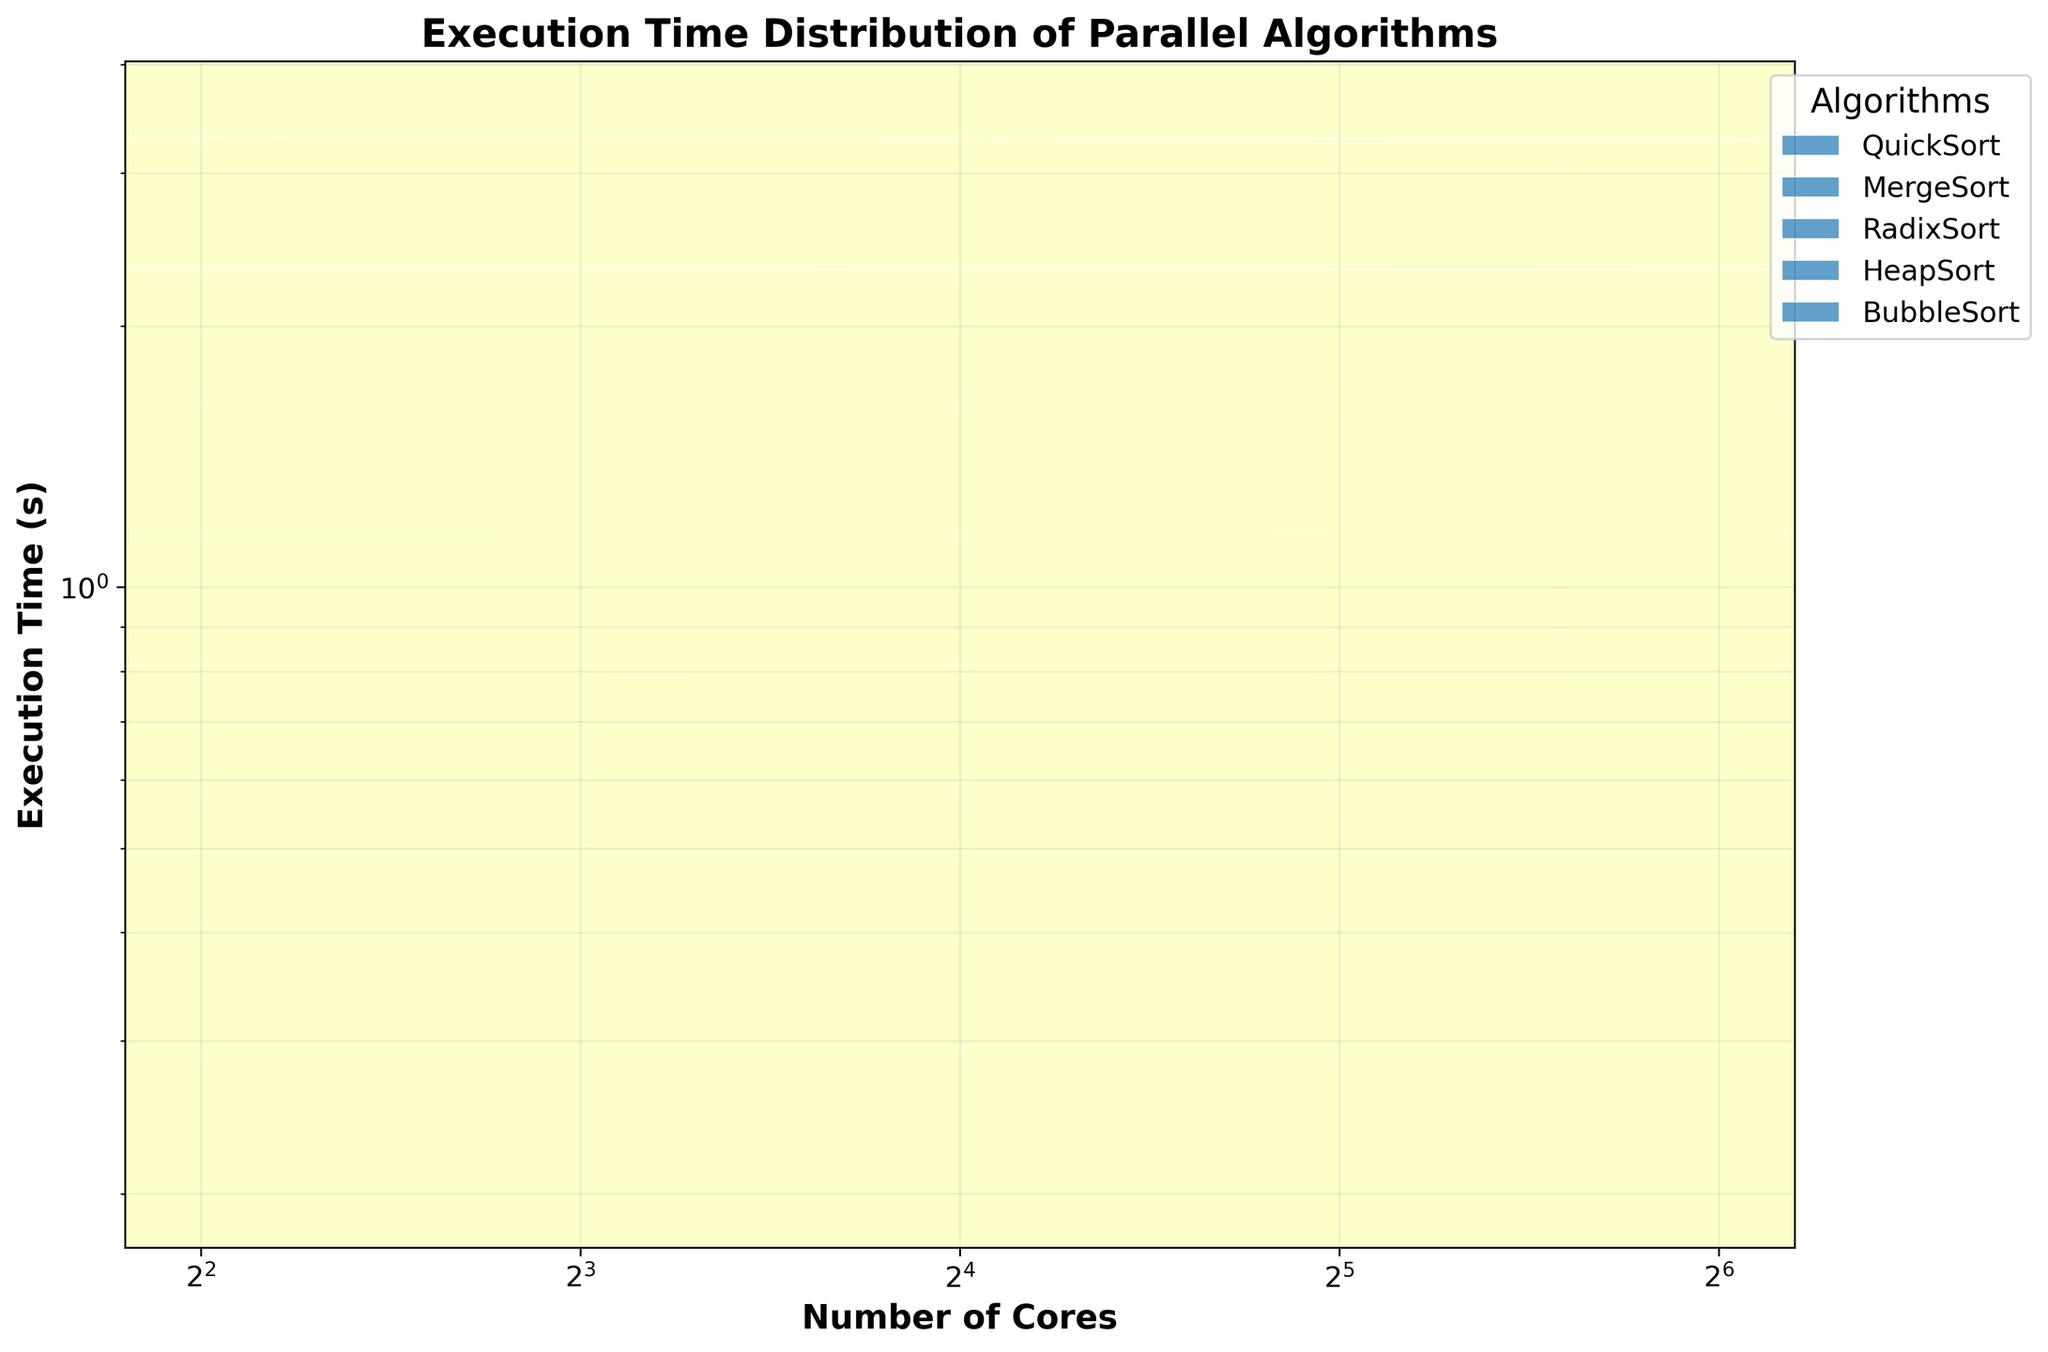What's the title of the figure? The title is displayed prominently at the top of the figure. In this case, it reads "Execution Time Distribution of Parallel Algorithms".
Answer: Execution Time Distribution of Parallel Algorithms What axes scales are used in the figure? The x-axis (Number of Cores) uses a log scale with base 2, and the y-axis (Execution Time) uses a log scale as well. This can be seen from the axis labels and tick marks.
Answer: Both axes use log scales How many unique algorithms are visualized in the plot? The legend lists all the algorithms represented in the plot. According to the legend, there are five algorithms: QuickSort, MergeSort, RadixSort, HeapSort, and BubbleSort.
Answer: Five Which algorithm has the lowest execution time for 64 cores? By inspecting the plot, you can see that HeapSort has the lowest execution time for 64 cores, as it appears at the bottom-most position among the various colored bins in that area.
Answer: HeapSort What is the general trend in execution time as the number of cores increases? Observing the figure, you can see that for all algorithms, the execution time generally decreases as the number of cores increases. This indicates that more cores lead to faster execution times.
Answer: Execution time decreases Which algorithm shows the least improvement in execution time when increasing cores from 4 to 64? Looking at the slopes of the hexbin distributions, RadixSort shows the least improvement in execution time from 4 cores to 64 cores, as the decrease in execution time is the smallest among the algorithms.
Answer: RadixSort Compare the reductions in execution time between QuickSort and BubbleSort from 4 to 64 cores. By comparing the positions of the hexbin plots for QuickSort and BubbleSort, QuickSort reduces from 1.2s to 0.2s (1.0s improvement), and BubbleSort reduces from 1.8s to 0.3s (1.5s improvement).
Answer: BubbleSort has greater reduction Which algorithm has the most clustered (densely packed) hexagons and what might this indicate? RadixSort’s hexagons are the most densely packed, particularly around the lower core counts. This indicates more consistent execution times for different core counts.
Answer: RadixSort Identify any outlier execution time values for any algorithm. There are no significant outlier data points far from the clusters for any of the algorithms, which suggests consistent behavior for each of the parallel algorithm implementations.
Answer: No major outliers 